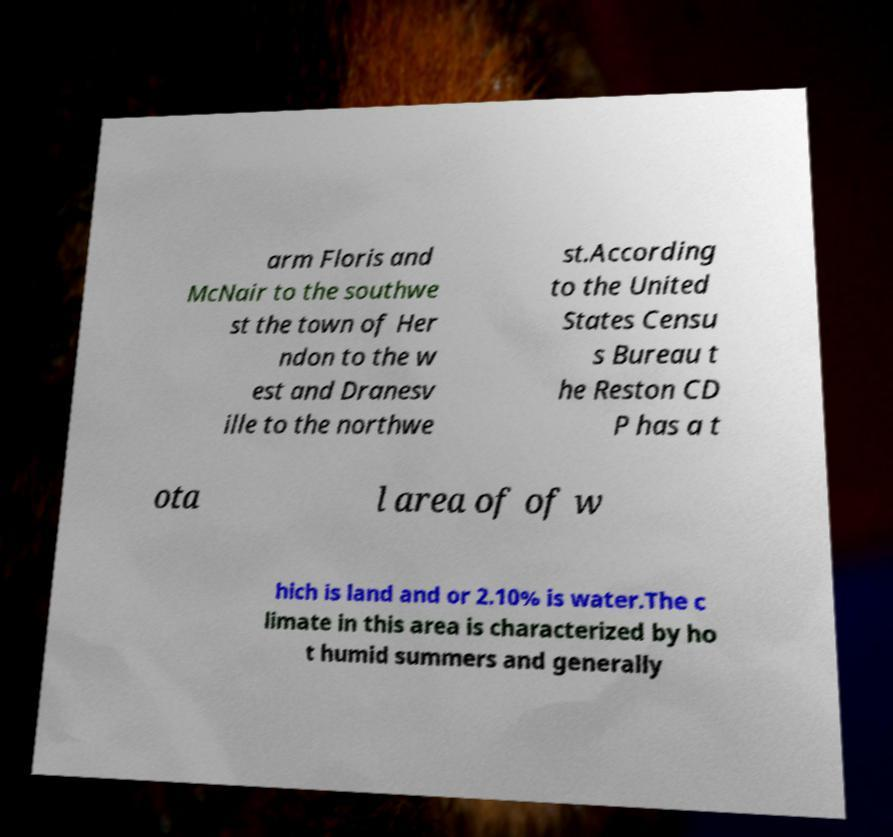Please read and relay the text visible in this image. What does it say? arm Floris and McNair to the southwe st the town of Her ndon to the w est and Dranesv ille to the northwe st.According to the United States Censu s Bureau t he Reston CD P has a t ota l area of of w hich is land and or 2.10% is water.The c limate in this area is characterized by ho t humid summers and generally 